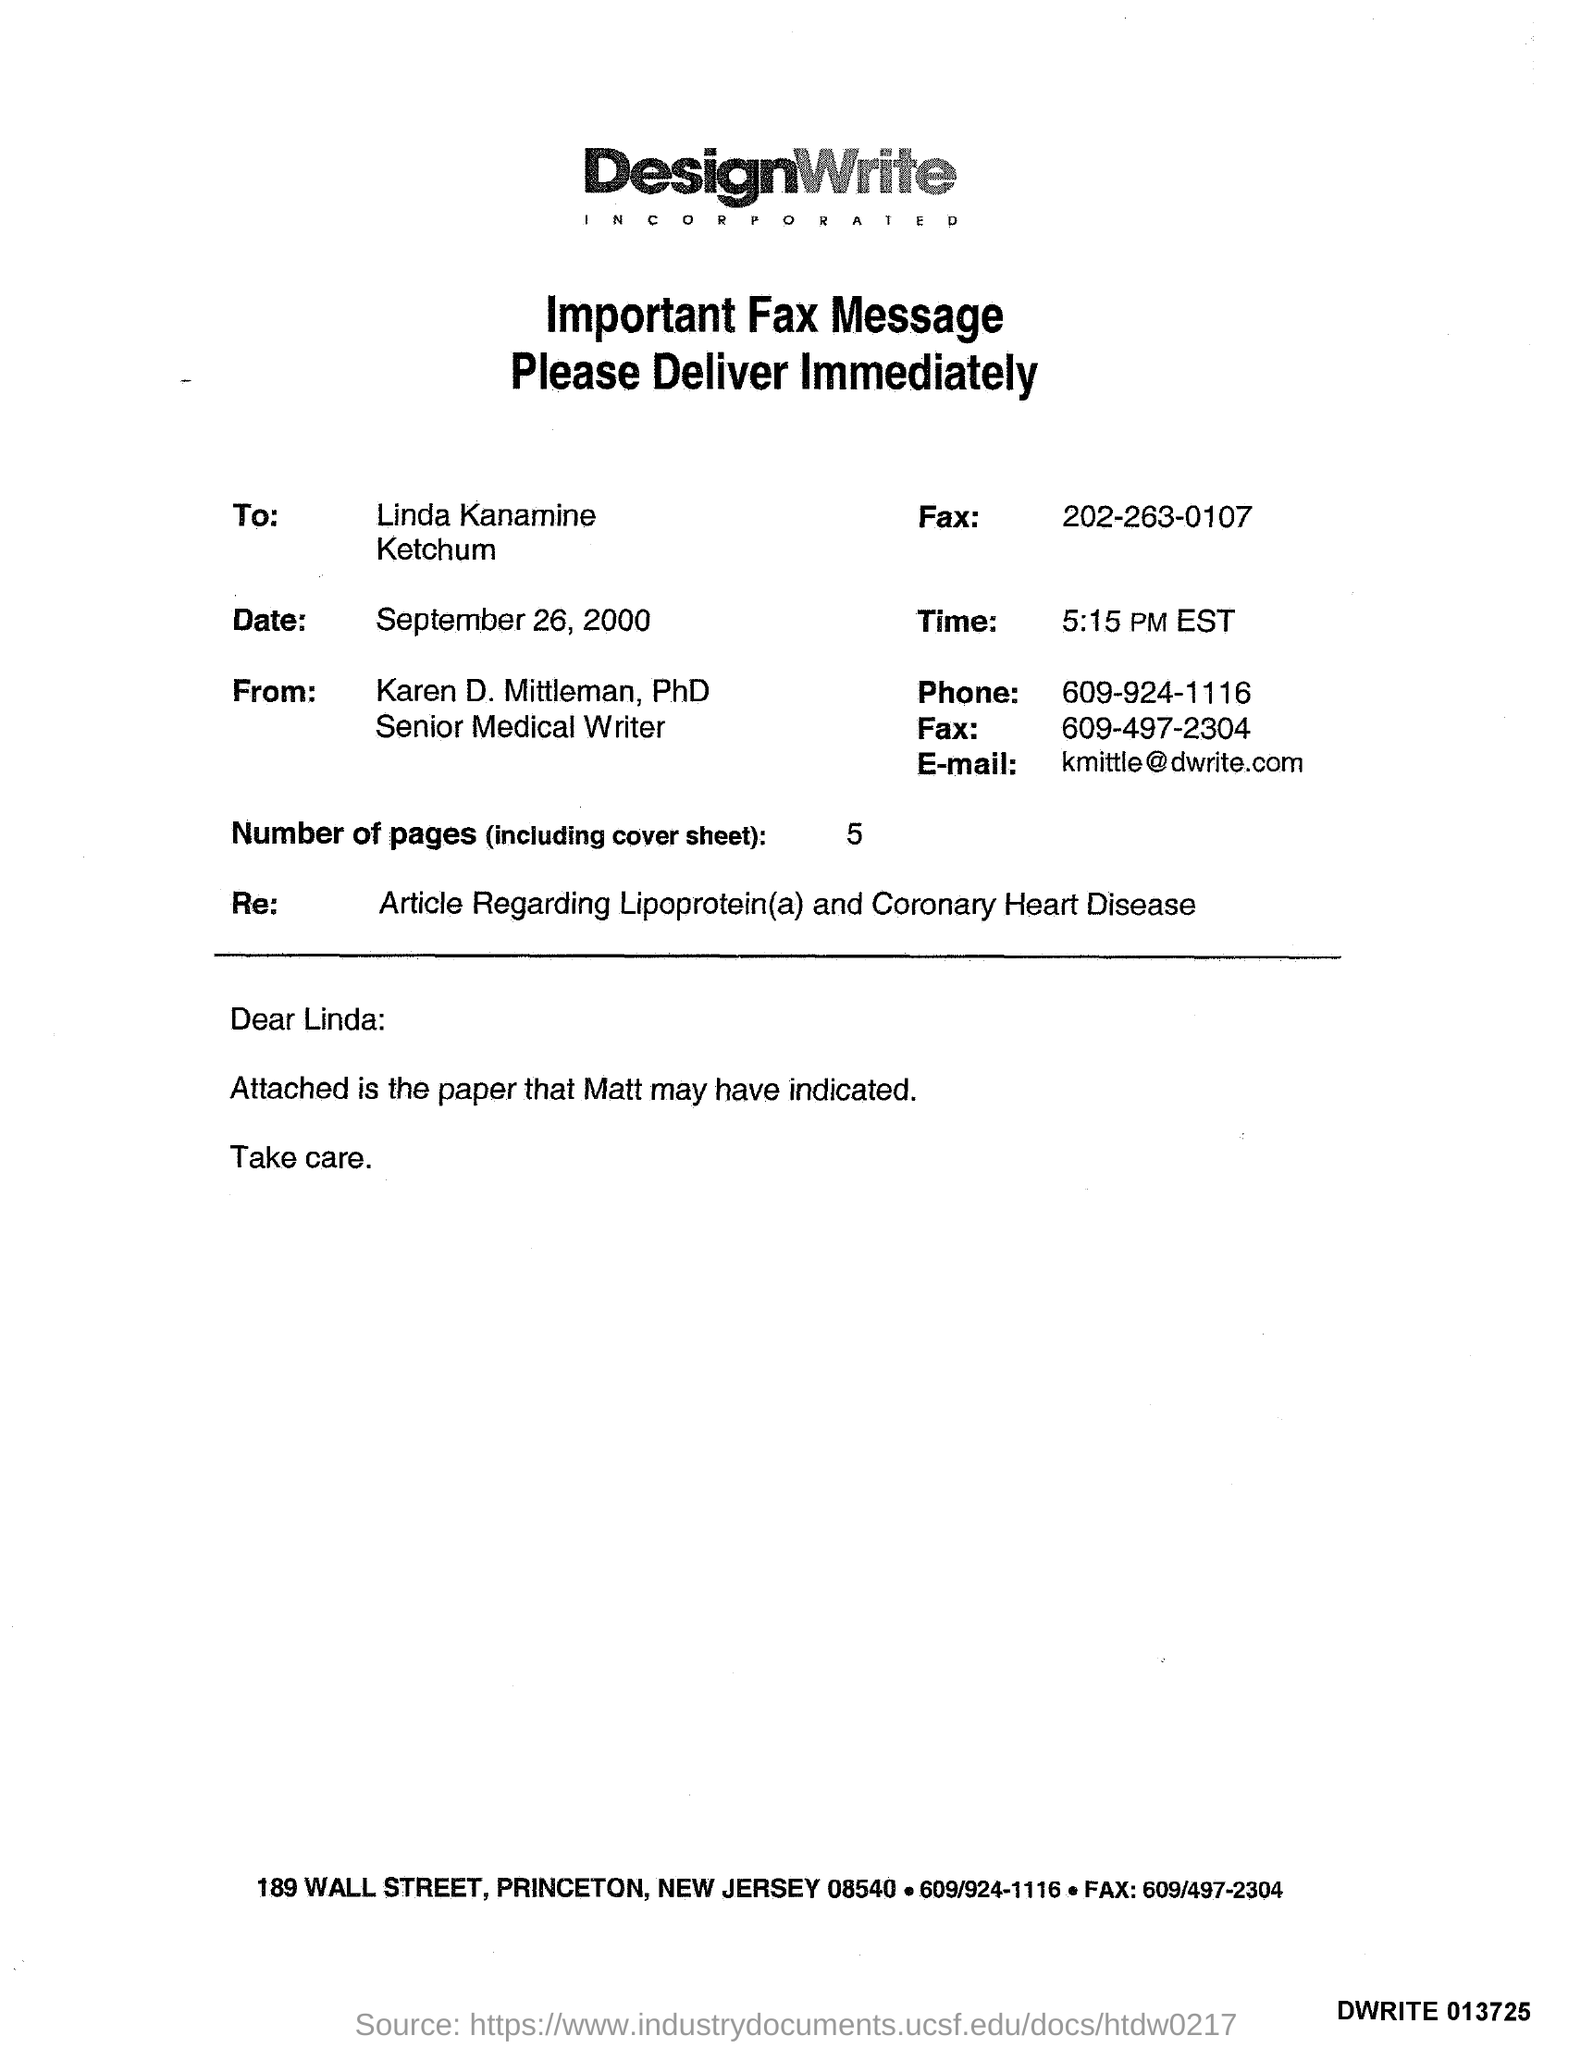What is the Receiver Fax Number ?
Offer a terse response. 202-263-0107. What is the Sender Fax Number ?
Give a very brief answer. 609-497-2304. How many pages are there?
Make the answer very short. 5. What is the Sender Phone Number ?
Provide a succinct answer. 609-924-1116. What is the date mentioned in the document ?
Keep it short and to the point. September 26, 2000. Who is the Senior Medical Writer ?
Your response must be concise. Karen Mittleman. 